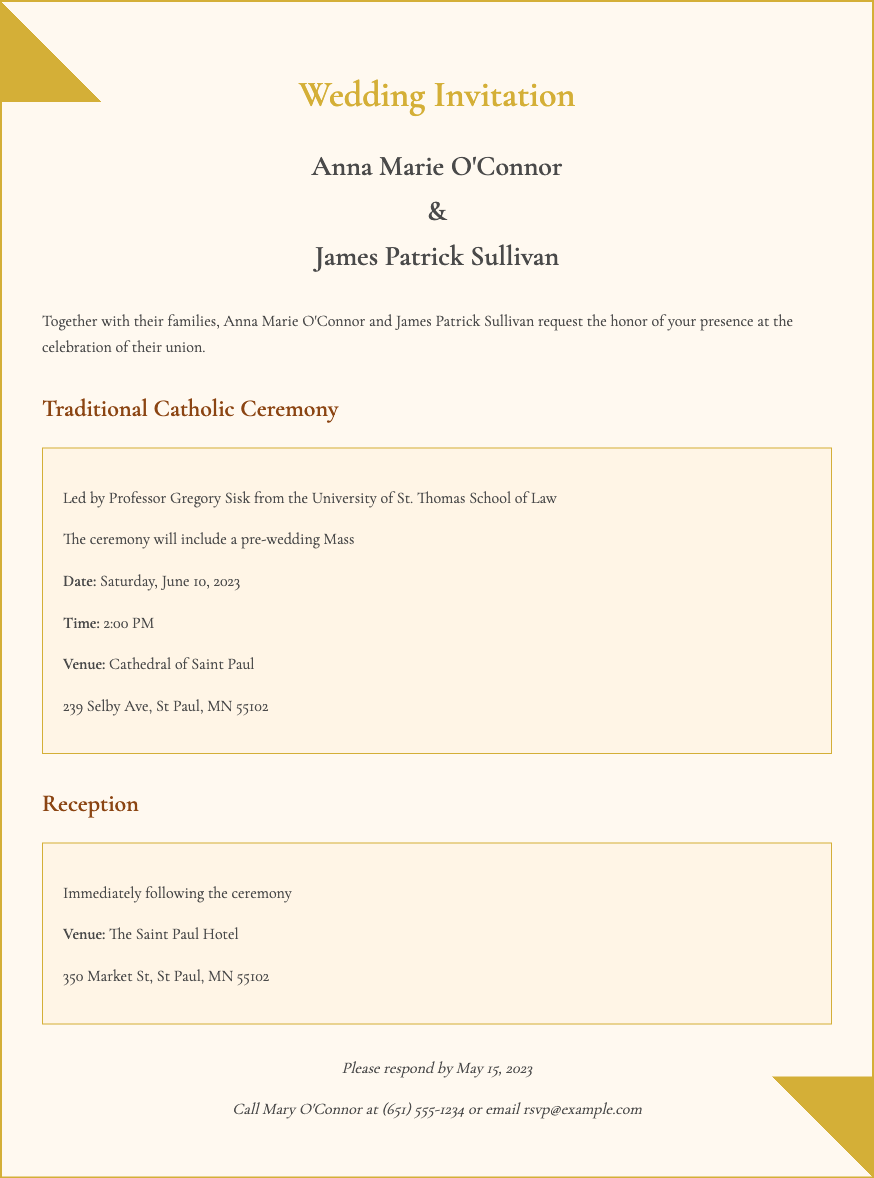What is the bride's name? The document explicitly states the bride's name is mentioned in the names section of the invitation.
Answer: Anna Marie O'Connor What is the groom's name? The document specifies the groom's name in the names section of the invitation.
Answer: James Patrick Sullivan What is the date of the wedding? The date of the wedding is clearly noted in the details of the ceremony section.
Answer: Saturday, June 10, 2023 What is the time of the ceremony? The time for the ceremony is distinctly mentioned in the details section of the invitation.
Answer: 2:00 PM Who is leading the ceremony? The invitation provides information about who will be leading the ceremony in the details section.
Answer: Professor Gregory Sisk What is the venue for the ceremony? The location of the ceremony is outlined in the details section of the invitation.
Answer: Cathedral of Saint Paul What is the RSVP deadline? The document includes a specific date by which guests should respond.
Answer: May 15, 2023 Where is the reception held? The venue for the reception is specified in the reception section of the invitation.
Answer: The Saint Paul Hotel What type of ceremony is being held? The invitation indicates the type of ceremony being performed in the Heading.
Answer: Traditional Catholic Ceremony What should guests do to RSVP? The document describes how guests can respond to the invitation in the RSVP section.
Answer: Call Mary O'Connor or email rsvp@example.com 